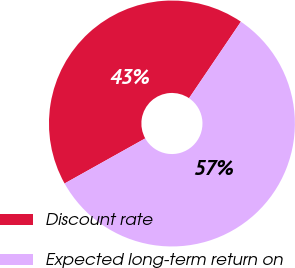Convert chart to OTSL. <chart><loc_0><loc_0><loc_500><loc_500><pie_chart><fcel>Discount rate<fcel>Expected long-term return on<nl><fcel>42.59%<fcel>57.41%<nl></chart> 